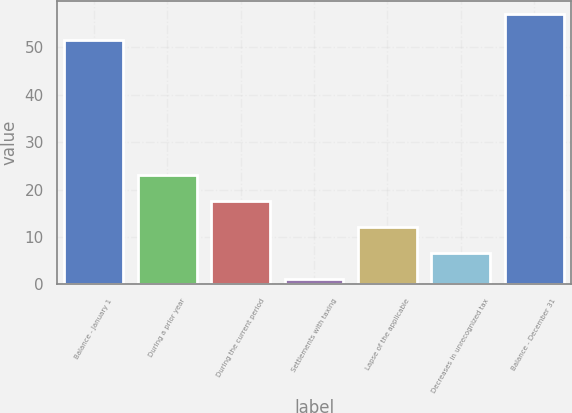<chart> <loc_0><loc_0><loc_500><loc_500><bar_chart><fcel>Balance - January 1<fcel>During a prior year<fcel>During the current period<fcel>Settlements with taxing<fcel>Lapse of the applicable<fcel>Decreases in unrecognized tax<fcel>Balance - December 31<nl><fcel>51.5<fcel>23.1<fcel>17.6<fcel>1.1<fcel>12.1<fcel>6.6<fcel>57<nl></chart> 